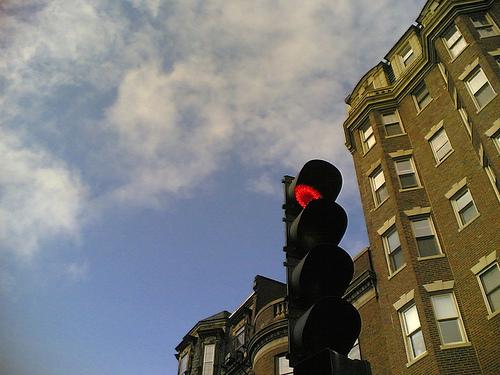What is in the sky?
Short answer required. Clouds. How many lights on this stoplight are probably green?
Concise answer only. 2. What color is the bottom light on the pole?
Give a very brief answer. Black. 